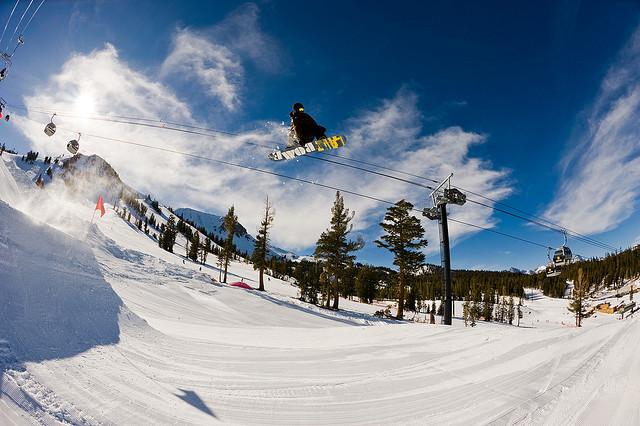Is the skier wearing white clothes?
Answer briefly. No. Is the person flying?
Write a very short answer. Yes. Is it raining?
Write a very short answer. No. 